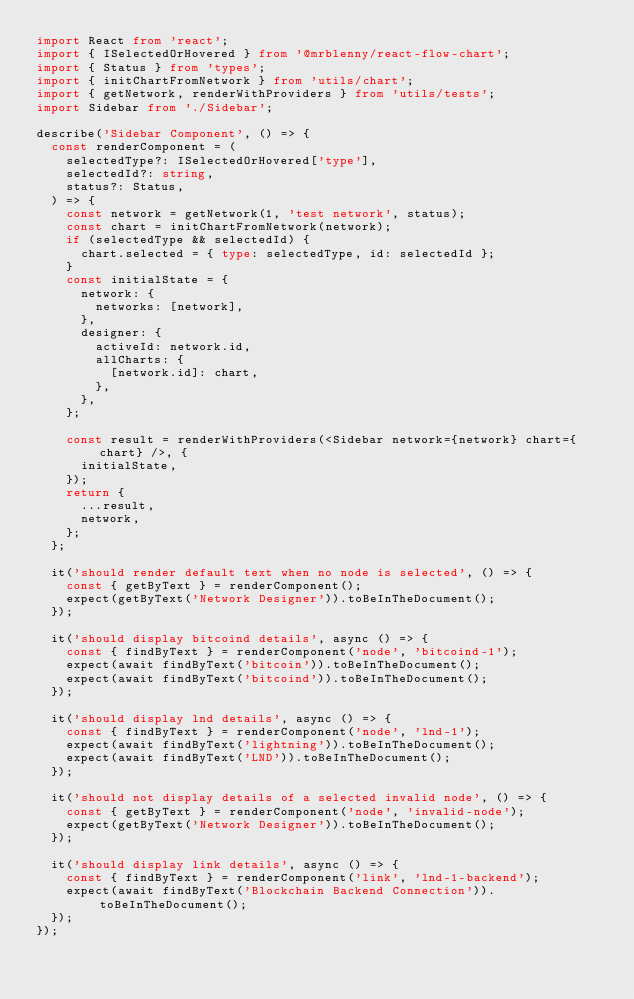<code> <loc_0><loc_0><loc_500><loc_500><_TypeScript_>import React from 'react';
import { ISelectedOrHovered } from '@mrblenny/react-flow-chart';
import { Status } from 'types';
import { initChartFromNetwork } from 'utils/chart';
import { getNetwork, renderWithProviders } from 'utils/tests';
import Sidebar from './Sidebar';

describe('Sidebar Component', () => {
  const renderComponent = (
    selectedType?: ISelectedOrHovered['type'],
    selectedId?: string,
    status?: Status,
  ) => {
    const network = getNetwork(1, 'test network', status);
    const chart = initChartFromNetwork(network);
    if (selectedType && selectedId) {
      chart.selected = { type: selectedType, id: selectedId };
    }
    const initialState = {
      network: {
        networks: [network],
      },
      designer: {
        activeId: network.id,
        allCharts: {
          [network.id]: chart,
        },
      },
    };

    const result = renderWithProviders(<Sidebar network={network} chart={chart} />, {
      initialState,
    });
    return {
      ...result,
      network,
    };
  };

  it('should render default text when no node is selected', () => {
    const { getByText } = renderComponent();
    expect(getByText('Network Designer')).toBeInTheDocument();
  });

  it('should display bitcoind details', async () => {
    const { findByText } = renderComponent('node', 'bitcoind-1');
    expect(await findByText('bitcoin')).toBeInTheDocument();
    expect(await findByText('bitcoind')).toBeInTheDocument();
  });

  it('should display lnd details', async () => {
    const { findByText } = renderComponent('node', 'lnd-1');
    expect(await findByText('lightning')).toBeInTheDocument();
    expect(await findByText('LND')).toBeInTheDocument();
  });

  it('should not display details of a selected invalid node', () => {
    const { getByText } = renderComponent('node', 'invalid-node');
    expect(getByText('Network Designer')).toBeInTheDocument();
  });

  it('should display link details', async () => {
    const { findByText } = renderComponent('link', 'lnd-1-backend');
    expect(await findByText('Blockchain Backend Connection')).toBeInTheDocument();
  });
});
</code> 